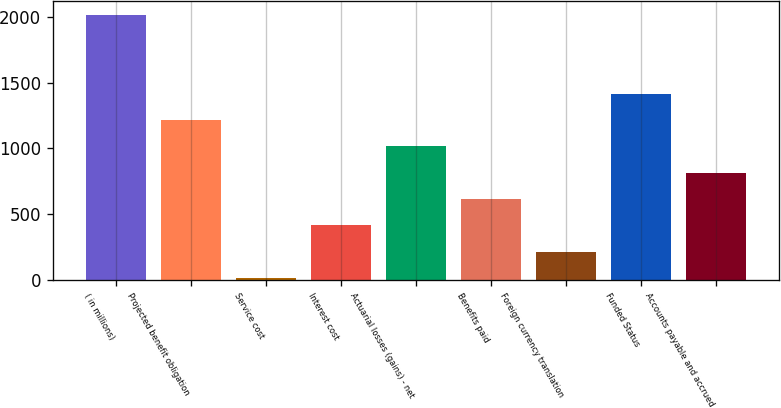<chart> <loc_0><loc_0><loc_500><loc_500><bar_chart><fcel>( in millions)<fcel>Projected benefit obligation<fcel>Service cost<fcel>Interest cost<fcel>Actuarial losses (gains) - net<fcel>Benefits paid<fcel>Foreign currency translation<fcel>Funded Status<fcel>Accounts payable and accrued<nl><fcel>2015<fcel>1215.4<fcel>16<fcel>415.8<fcel>1015.5<fcel>615.7<fcel>215.9<fcel>1415.3<fcel>815.6<nl></chart> 